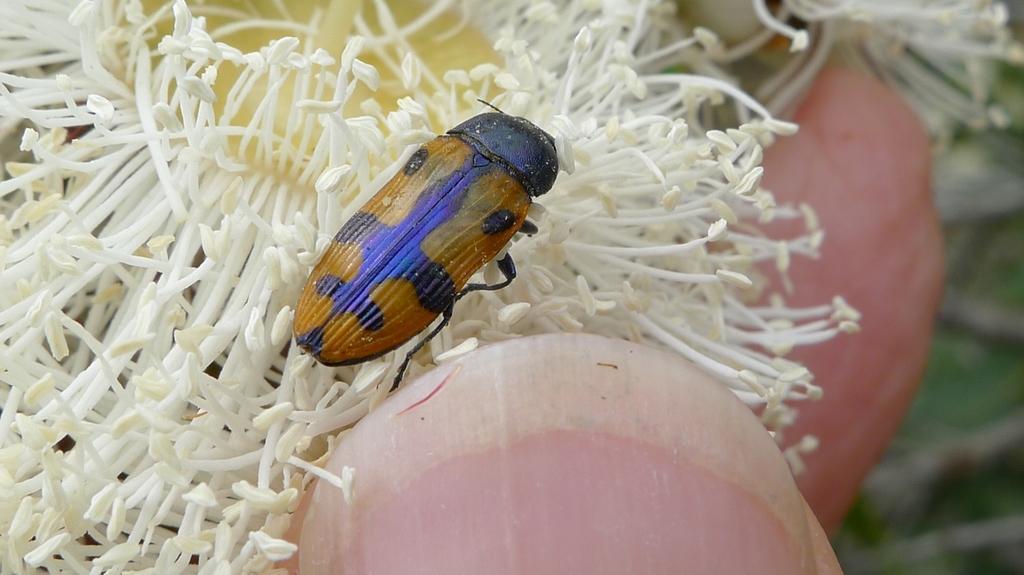Describe this image in one or two sentences. In this image I can see a yellow and black colour insect. I can also see white colour things and here I can see nail of a person. 